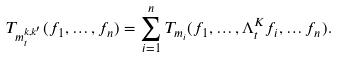<formula> <loc_0><loc_0><loc_500><loc_500>T _ { m ^ { k , k ^ { \prime } } _ { t } } ( f _ { 1 } , \dots , f _ { n } ) = \sum _ { i = 1 } ^ { n } T _ { m _ { i } } ( f _ { 1 } , \dots , \Lambda _ { t } ^ { K } f _ { i } , \dots f _ { n } ) .</formula> 